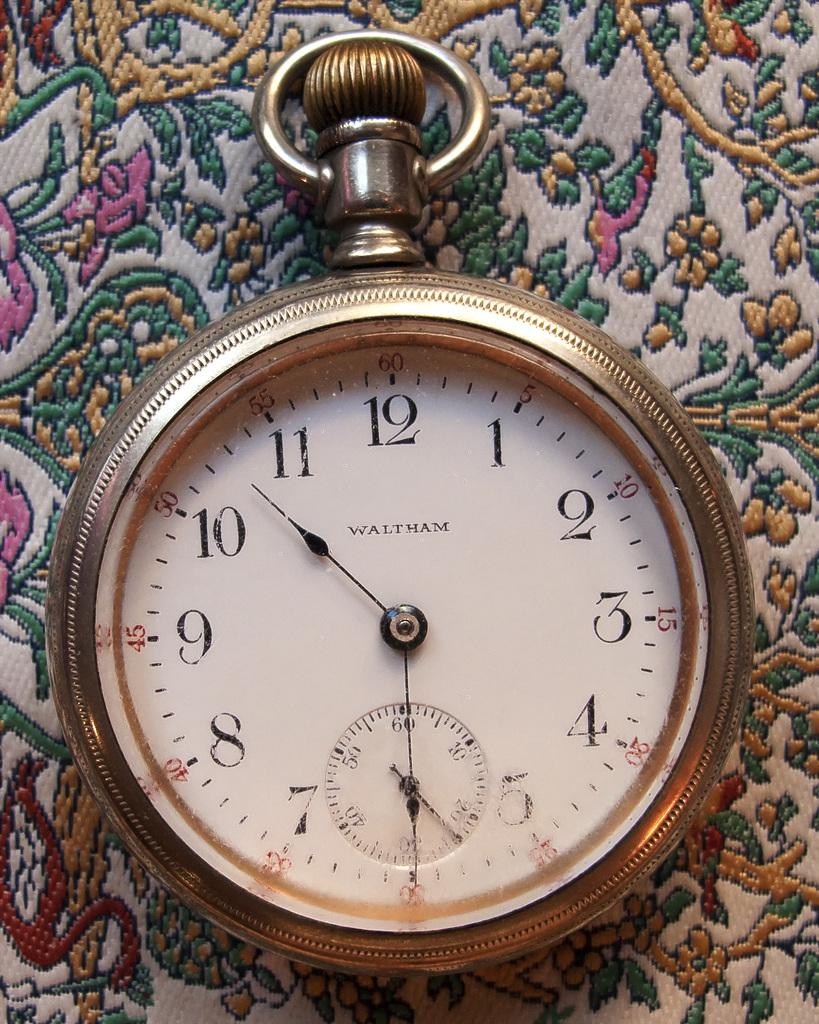<image>
Offer a succinct explanation of the picture presented. the number 12 is on the watch item 